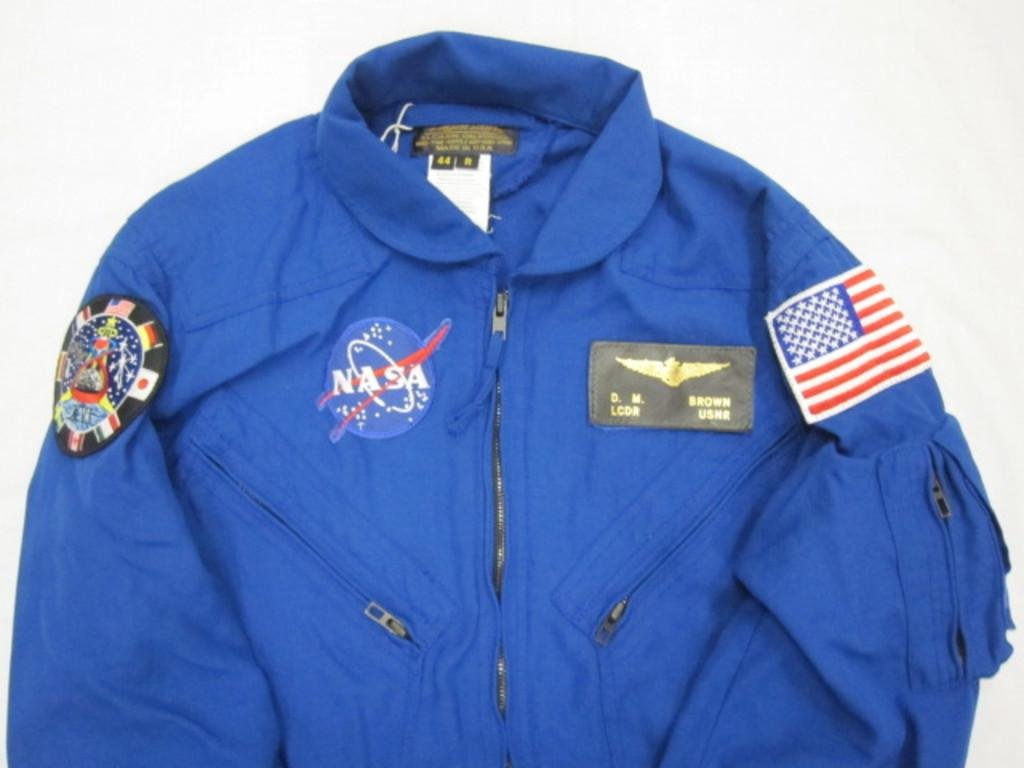What type of clothing item is in the image? There is a shirt in the image. What color is the shirt? The shirt is blue in color. What design elements are present on the shirt? The shirt has logos and flags on it. How many men are looking at the floor in the image? There is no mention of men or looking at the floor in the image; it only features a blue shirt with logos and flags on it. 